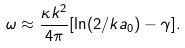Convert formula to latex. <formula><loc_0><loc_0><loc_500><loc_500>\omega \approx \frac { \kappa k ^ { 2 } } { 4 \pi } [ \ln ( 2 / k a _ { 0 } ) - \gamma ] .</formula> 